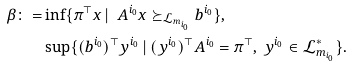<formula> <loc_0><loc_0><loc_500><loc_500>\beta \colon = & \inf \{ \pi ^ { \top } x \, | \ \ A ^ { i _ { 0 } } x \succeq _ { \mathcal { L } _ { m _ { i _ { 0 } } } } b ^ { i _ { 0 } } \} , \\ & \sup \{ ( b ^ { i _ { 0 } } ) ^ { \top } y ^ { i _ { 0 } } \, | \ ( y ^ { i _ { 0 } } ) ^ { \top } A ^ { i _ { 0 } } = \pi ^ { \top } , \ y ^ { i _ { 0 } } \in \mathcal { L } ^ { * } _ { m _ { i _ { 0 } } } \} .</formula> 